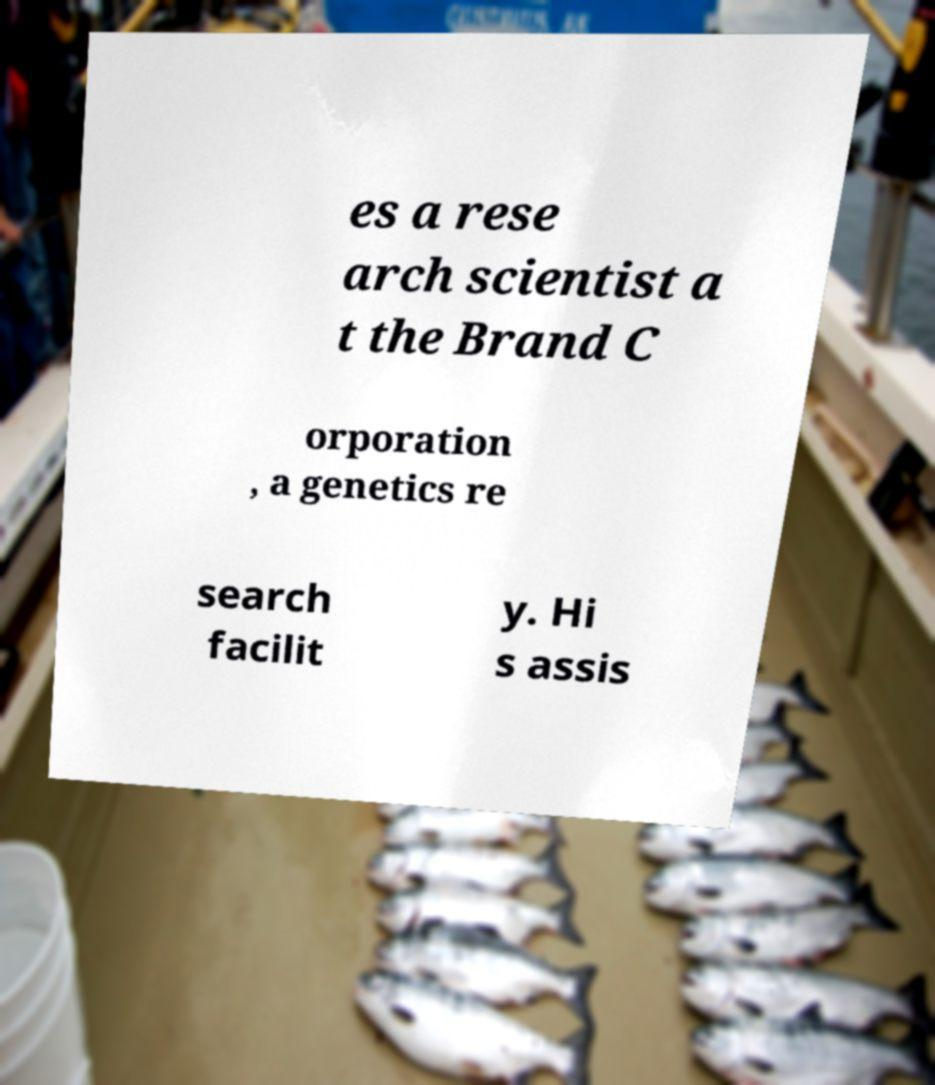What messages or text are displayed in this image? I need them in a readable, typed format. es a rese arch scientist a t the Brand C orporation , a genetics re search facilit y. Hi s assis 